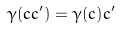Convert formula to latex. <formula><loc_0><loc_0><loc_500><loc_500>\gamma ( c c ^ { \prime } ) = \gamma ( c ) c ^ { \prime }</formula> 